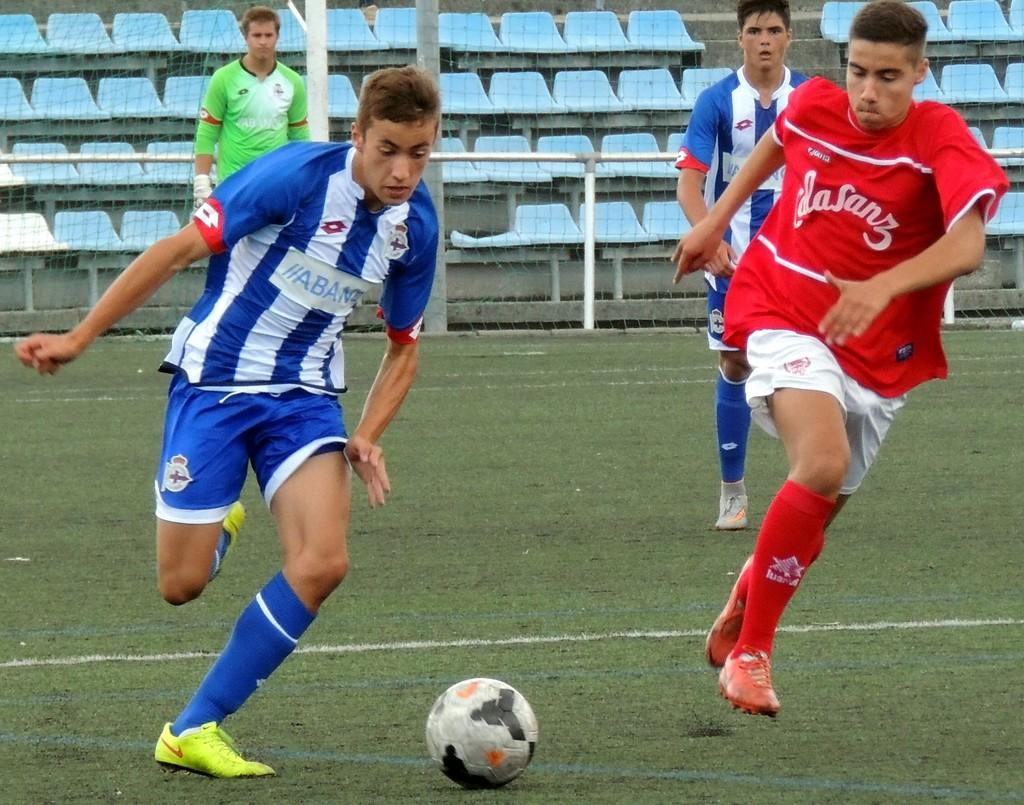How many people are present in the image? There are four people in the image. What are the people doing in the image? The people are playing in the image. What object is associated with their play in the image? There is a ball in the image. What is the name of the porter in the image? There is no porter present in the image. Can you recall the memory of the people in the image from a previous encounter? The image does not provide any information about previous encounters or memories of the people. 